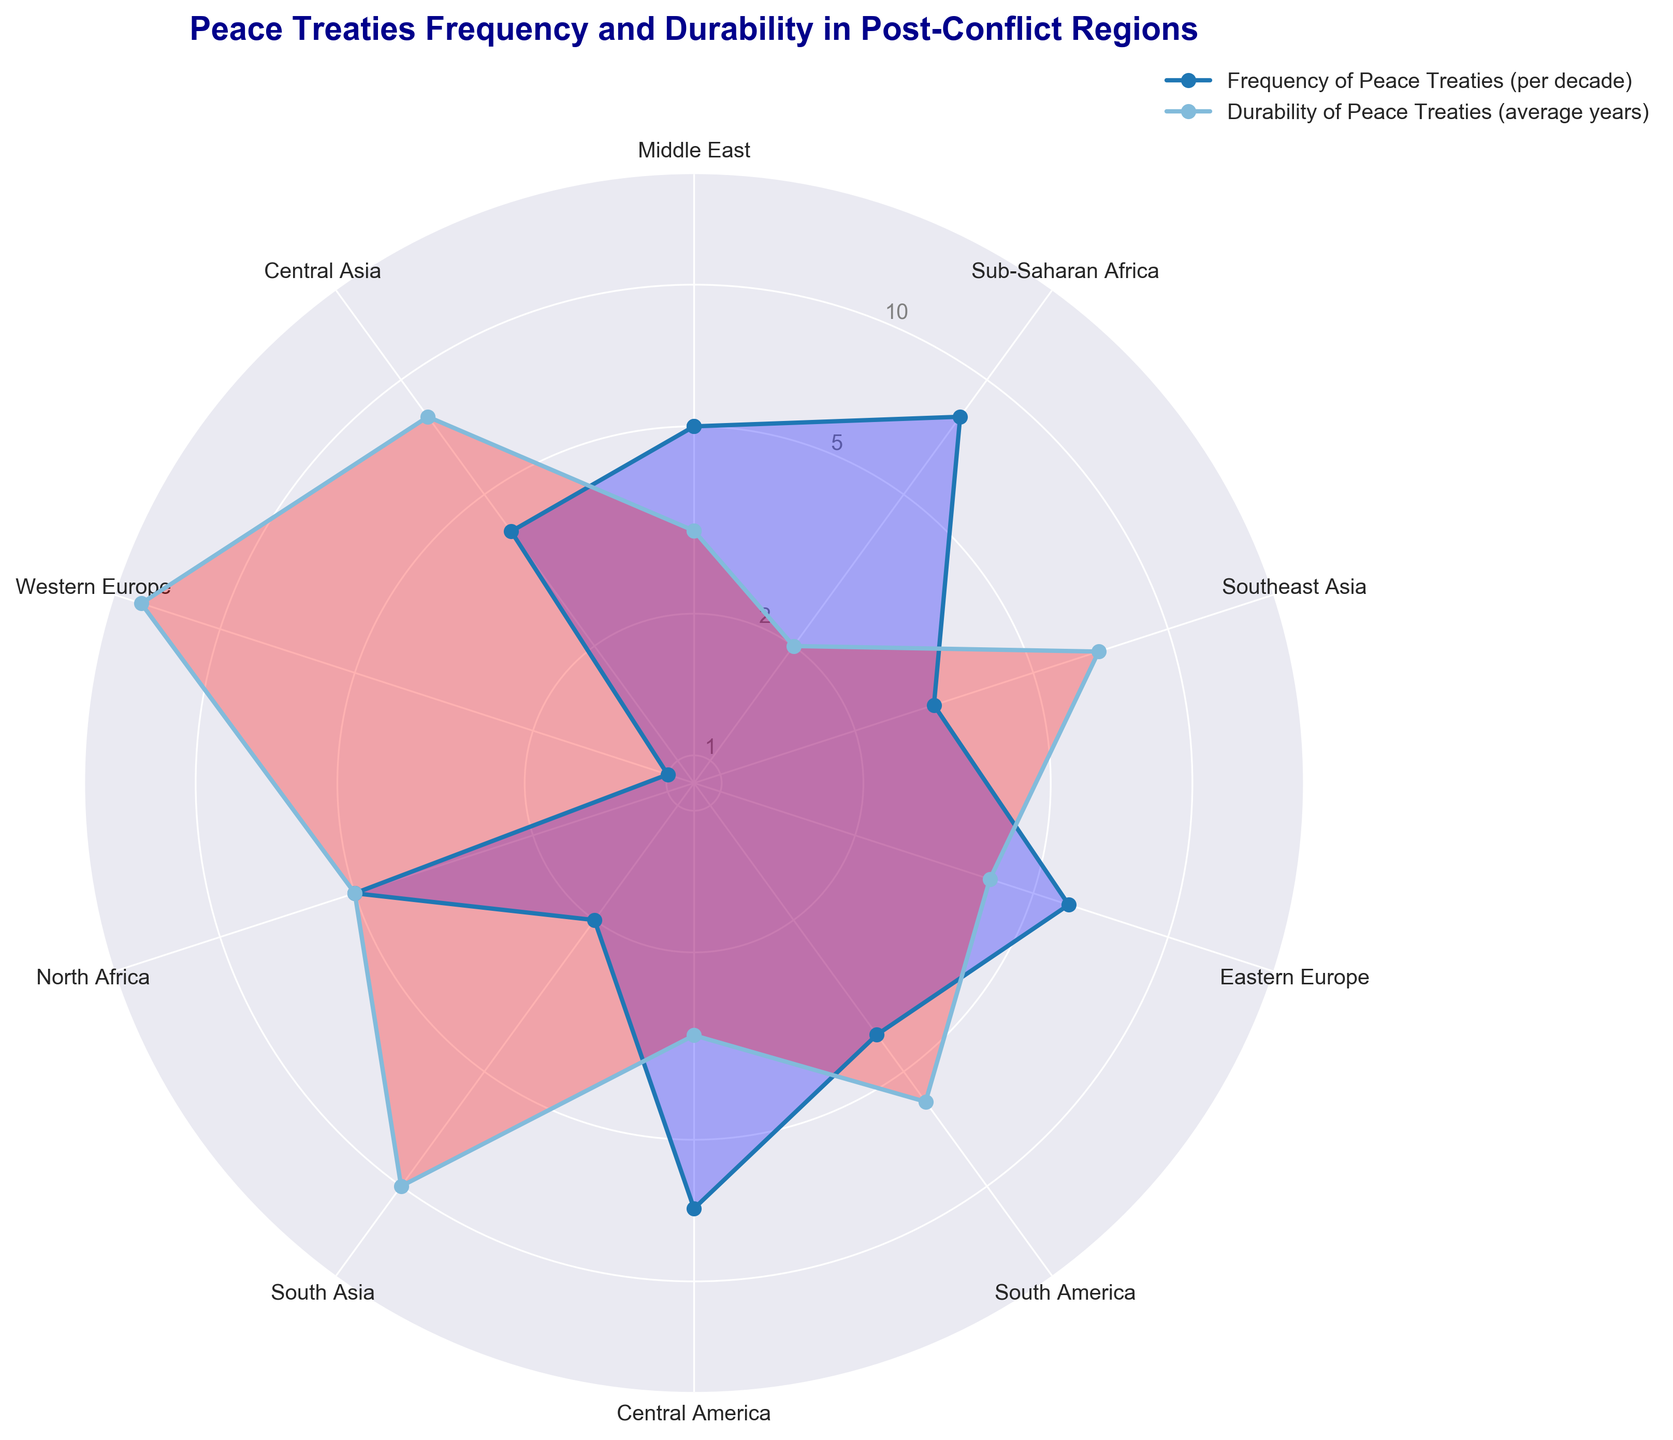Which region has the highest frequency of peace treaties per decade? According to the radar chart, Sub-Saharan Africa has the highest point on the Frequency of Peace Treaties axis, indicating the highest frequency.
Answer: Sub-Saharan Africa How does the durability of peace treaties in South Asia compare to that in Western Europe? Western Europe has a durability of 15 years, while South Asia has a durability of 10 years. Thus, Western Europe has a higher durability.
Answer: Western Europe has higher durability Which region has the lowest durability of peace treaties? The radar chart shows that Sub-Saharan Africa has the lowest point on the Durability axis at 2 years.
Answer: Sub-Saharan Africa What is the average frequency of peace treaties per decade for Central America and Northeast Asia? According to the radar chart, Central America has a frequency of 7 and Northeast Asia (interpreted as Eastern Europe since it's missing in the data) has a frequency of 6. Average: (7+6)/2 = 6.5.
Answer: 6.5 In which region do peace treaties last longer on average compared to the Middle East? The Middle East has a durability of 3 years. Regions with higher durability: Southeast Asia (7), South America (6), North Africa (5), South Asia (10), Western Europe (15), Central Asia (8).
Answer: Southeast Asia, South America, North Africa, South Asia, Western Europe, Central Asia Between which regions is there the largest difference in the frequency of peace treaties per decade? Sub-Saharan Africa has the highest frequency at 8, and Western Europe has the lowest at 1. The difference is 8 - 1 = 7.
Answer: Sub-Saharan Africa and Western Europe Which regions have a durability of treaties that is equal or greater than 5 years? The radar chart shows North Africa (5), Southeast Asia (7), South America (6), South Asia (10), Western Europe (15), and Central Asia (8).
Answer: North Africa, Southeast Asia, South America, South Asia, Western Europe, Central Asia What is the median frequency of peace treaties per decade across all regions depicted? To find the median, order the frequencies: 1, 2, 3, 4, 4, 5, 5, 6, 7, 8. The middle values are 4 and 5. Average them: (4+5)/2 = 4.5.
Answer: 4.5 